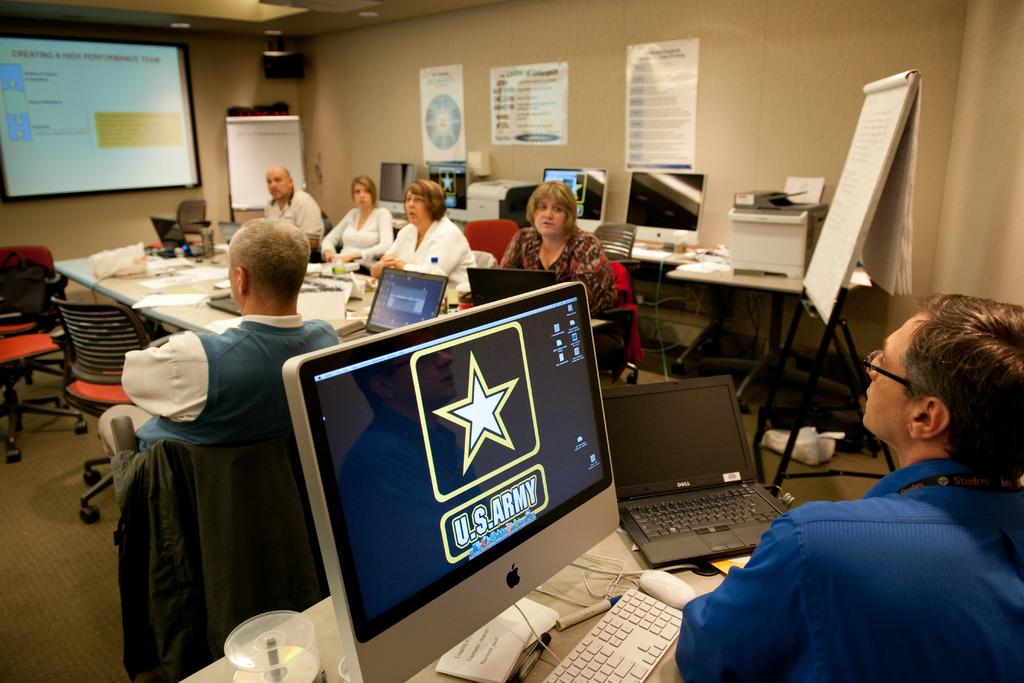Provide a one-sentence caption for the provided image. A group of people are gathered in a room for a meeting, with the US Army logo up on a apple computer. 